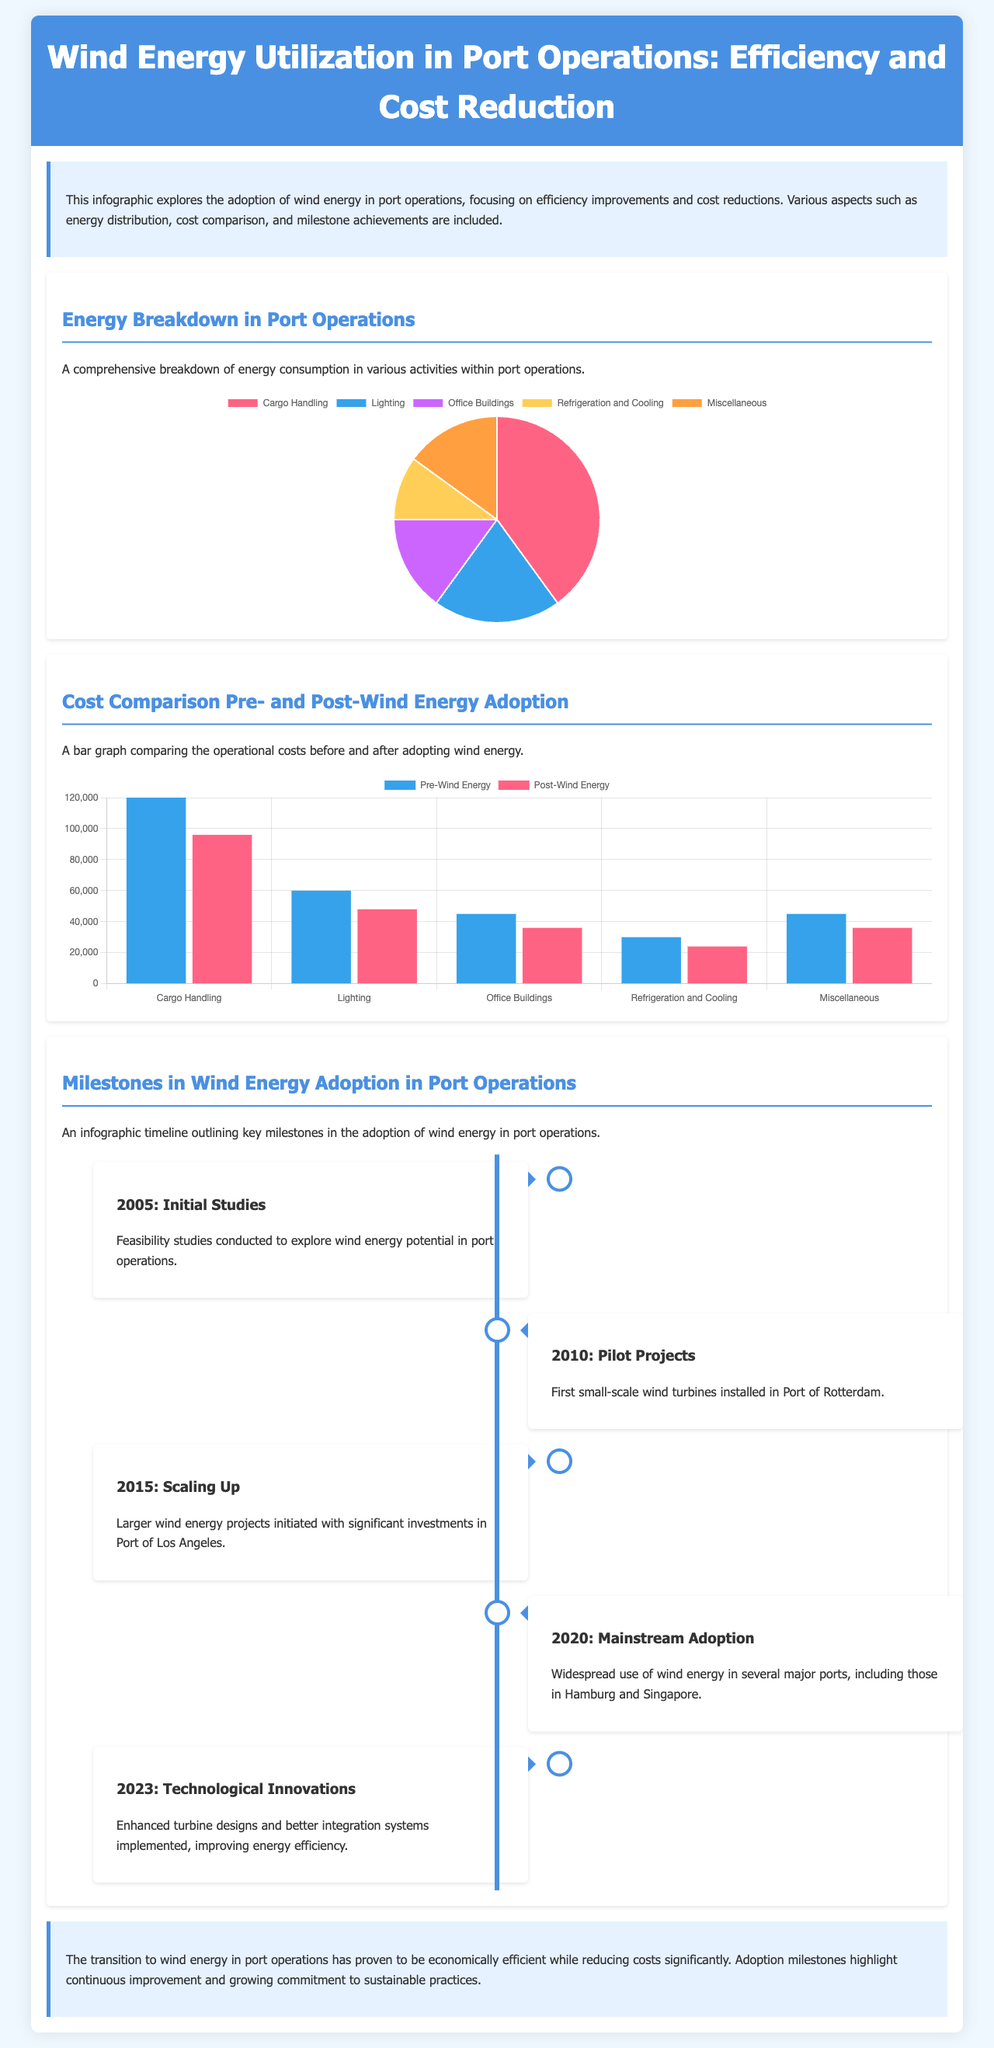What is the largest energy consumer in port operations? The pie chart indicates that Cargo Handling is the largest consumer of energy in port operations.
Answer: Cargo Handling What percentage of energy is used for Refrigeration and Cooling? From the pie chart, Refrigeration and Cooling accounts for 10% of the total energy used in port operations.
Answer: 10% How much was the operational cost for Lighting before wind energy adoption? The bar chart shows that the cost for Lighting before wind energy adoption was 60,000.
Answer: 60,000 What was the cost reduction in Miscellaneous activities after adopting wind energy? The difference between pre- and post-wind energy costs for Miscellaneous is 45,000 - 36,000, which equals 9,000.
Answer: 9,000 When did the pilot projects for wind energy start in port operations? The timeline indicates that pilot projects commenced in 2010.
Answer: 2010 What key event occurred in 2023? According to the timeline, 2023 saw technological innovations in wind energy integration and turbine designs.
Answer: Technological Innovations How many key milestones are outlined in the infographic timeline? The timeline includes a total of five key milestones related to wind energy adoption in port operations.
Answer: Five What color represents the pre-wind energy costs in the bar chart? The color representing pre-wind energy costs in the bar chart is blue.
Answer: Blue What type of chart is used to depict the energy breakdown? The energy breakdown is depicted using a pie chart.
Answer: Pie Chart 